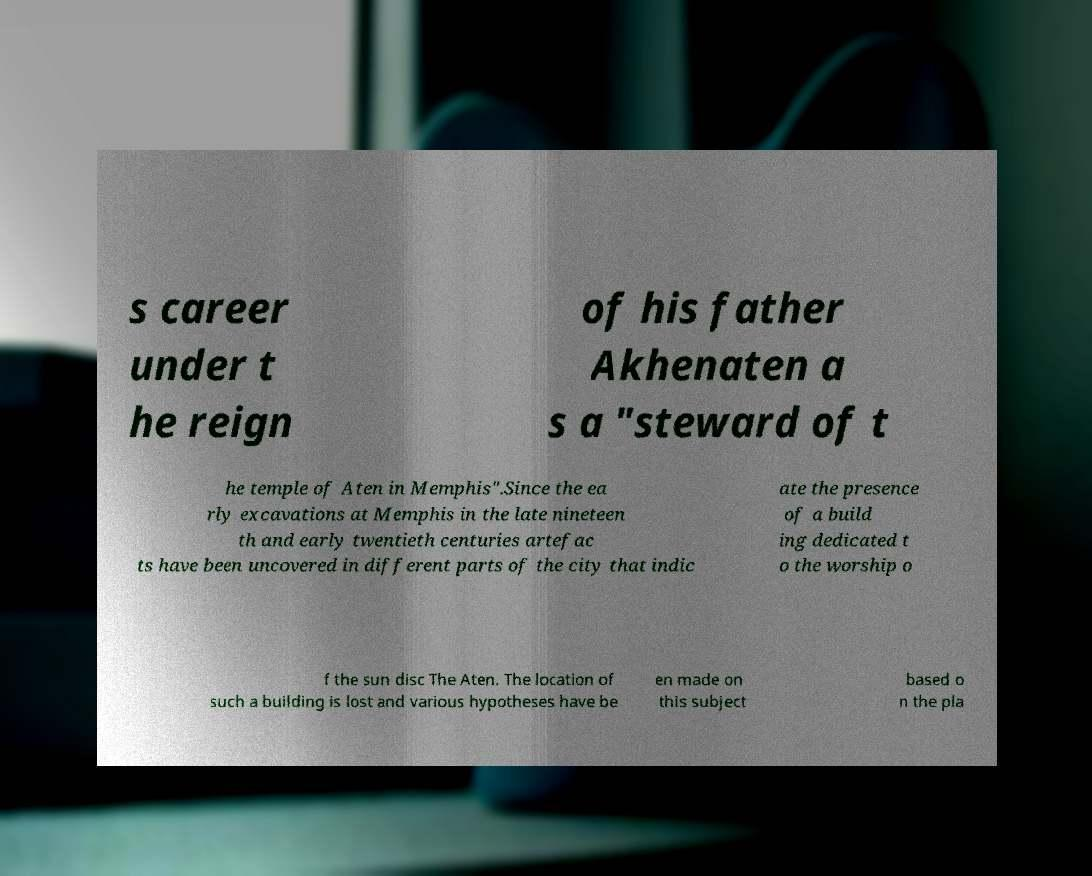For documentation purposes, I need the text within this image transcribed. Could you provide that? s career under t he reign of his father Akhenaten a s a "steward of t he temple of Aten in Memphis".Since the ea rly excavations at Memphis in the late nineteen th and early twentieth centuries artefac ts have been uncovered in different parts of the city that indic ate the presence of a build ing dedicated t o the worship o f the sun disc The Aten. The location of such a building is lost and various hypotheses have be en made on this subject based o n the pla 